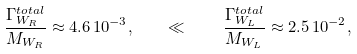<formula> <loc_0><loc_0><loc_500><loc_500>\frac { \Gamma ^ { t o t a l } _ { W _ { R } } } { M _ { W _ { R } } } \approx 4 . 6 \, 1 0 ^ { - 3 } , \quad \ll \quad \frac { \Gamma ^ { t o t a l } _ { W _ { L } } } { M _ { W _ { L } } } \approx 2 . 5 \, 1 0 ^ { - 2 } ,</formula> 